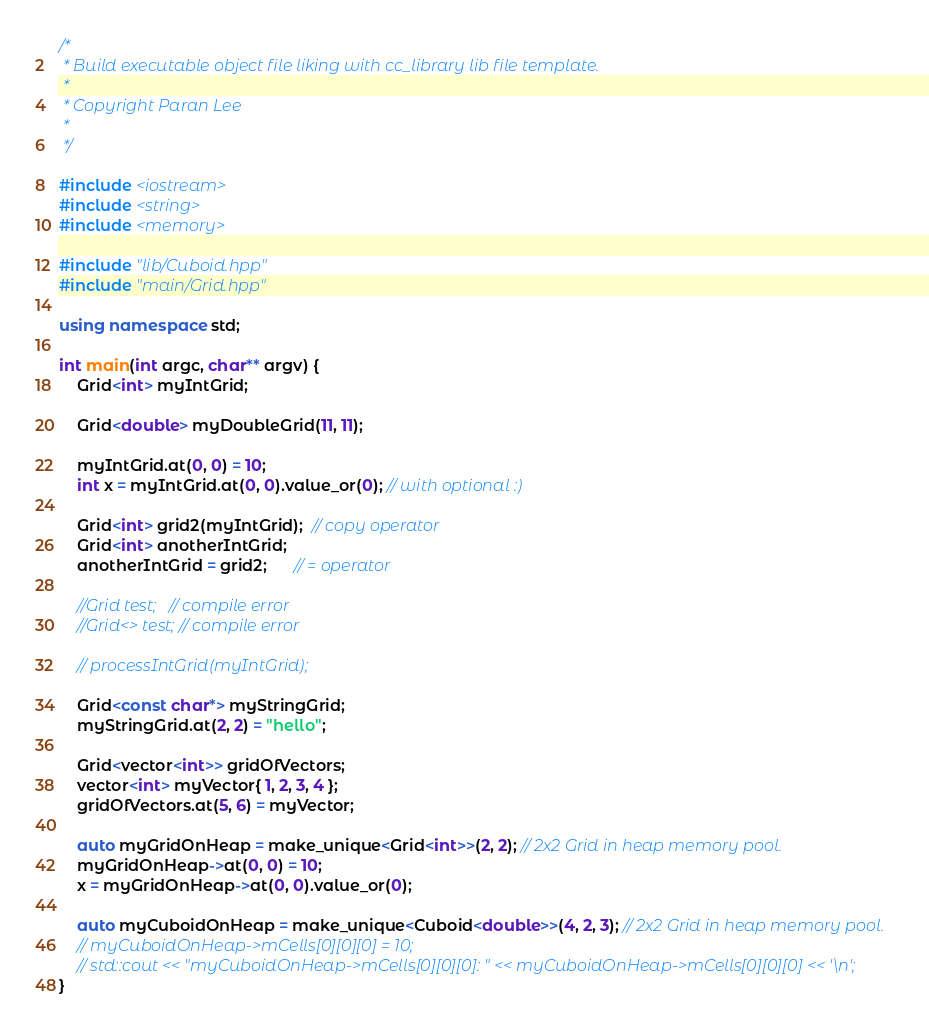<code> <loc_0><loc_0><loc_500><loc_500><_C++_>/*
 * Build executable object file liking with cc_library lib file template.
 *
 * Copyright Paran Lee
 *
 */

#include <iostream>
#include <string>
#include <memory>

#include "lib/Cuboid.hpp"
#include "main/Grid.hpp"

using namespace std;

int main(int argc, char** argv) {
    Grid<int> myIntGrid;

    Grid<double> myDoubleGrid(11, 11); 

    myIntGrid.at(0, 0) = 10;
    int x = myIntGrid.at(0, 0).value_or(0); // with optional :)

    Grid<int> grid2(myIntGrid);  // copy operator
    Grid<int> anotherIntGrid;
    anotherIntGrid = grid2;      // = operator

    //Grid test;   // compile error
    //Grid<> test; // compile error

    // processIntGrid(myIntGrid);

    Grid<const char*> myStringGrid;
    myStringGrid.at(2, 2) = "hello";

    Grid<vector<int>> gridOfVectors;
    vector<int> myVector{ 1, 2, 3, 4 };
    gridOfVectors.at(5, 6) = myVector;

    auto myGridOnHeap = make_unique<Grid<int>>(2, 2); // 2x2 Grid in heap memory pool.
    myGridOnHeap->at(0, 0) = 10;
    x = myGridOnHeap->at(0, 0).value_or(0);

    auto myCuboidOnHeap = make_unique<Cuboid<double>>(4, 2, 3); // 2x2 Grid in heap memory pool.
    // myCuboidOnHeap->mCells[0][0][0] = 10;
    // std::cout << "myCuboidOnHeap->mCells[0][0][0]: " << myCuboidOnHeap->mCells[0][0][0] << '\n';
}
</code> 